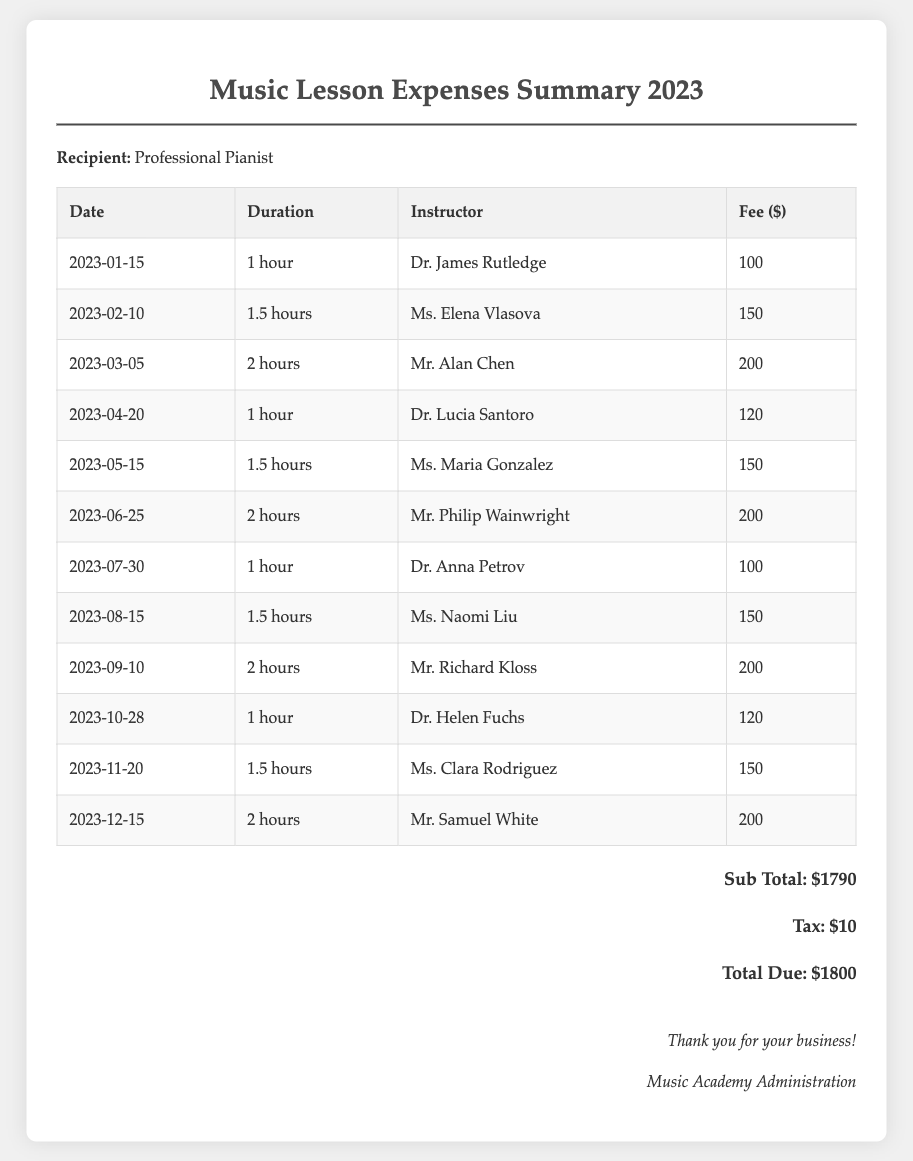what is the total due amount? The total due amount is calculated as the sum of the subtotal and tax, which equals $1790 + $10.
Answer: $1800 how many hours of lessons were taken on March 5, 2023? The duration of the lesson taken on March 5, 2023, is provided in the document as 2 hours.
Answer: 2 hours who was the instructor on June 25, 2023? The document states that the instructor for the lesson on June 25, 2023, was Mr. Philip Wainwright.
Answer: Mr. Philip Wainwright what is the fee for a 1.5-hour lesson? The document lists 1.5-hour lessons with a fee of $150 for multiple instances throughout the year.
Answer: $150 which month had a lesson with Dr. Helen Fuchs? According to the document, Dr. Helen Fuchs provided a lesson in October 2023.
Answer: October what is the subtotal of the lessons before tax? The subtotal refers to the total amount of fees for all lessons before tax is applied, as stated in the document.
Answer: $1790 how many lessons were taken in the year 2023? By counting the lessons listed in the document, the total number of lessons is determined.
Answer: 12 lessons what was the duration of the lesson on November 20, 2023? The document indicates that the lesson on November 20, 2023, lasted for 1.5 hours.
Answer: 1.5 hours what is the tax amount listed in the document? The document provides the tax amount that is added to the subtotal.
Answer: $10 